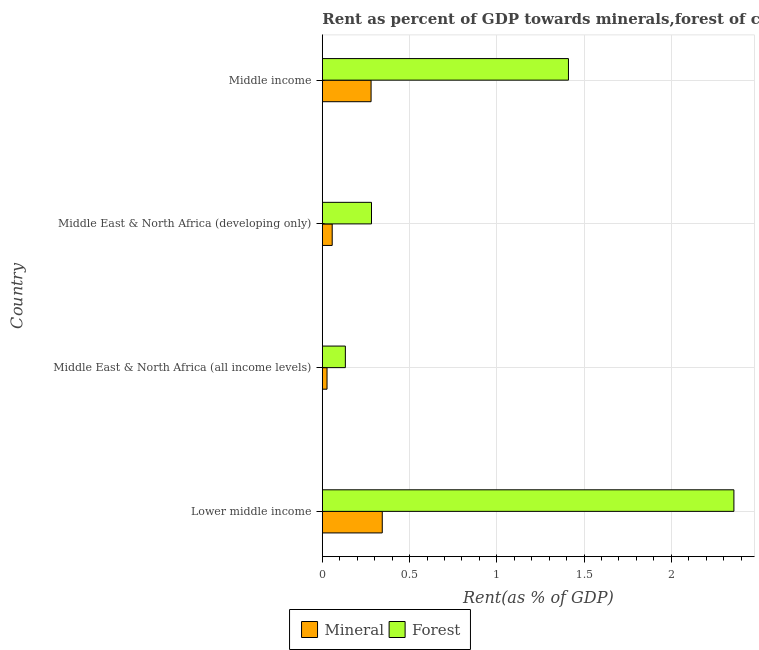How many bars are there on the 1st tick from the bottom?
Provide a succinct answer. 2. What is the label of the 4th group of bars from the top?
Keep it short and to the point. Lower middle income. In how many cases, is the number of bars for a given country not equal to the number of legend labels?
Make the answer very short. 0. What is the mineral rent in Middle income?
Your answer should be very brief. 0.28. Across all countries, what is the maximum mineral rent?
Make the answer very short. 0.34. Across all countries, what is the minimum forest rent?
Offer a terse response. 0.13. In which country was the forest rent maximum?
Ensure brevity in your answer.  Lower middle income. In which country was the mineral rent minimum?
Offer a terse response. Middle East & North Africa (all income levels). What is the total mineral rent in the graph?
Offer a terse response. 0.71. What is the difference between the forest rent in Middle East & North Africa (developing only) and that in Middle income?
Your answer should be very brief. -1.13. What is the difference between the mineral rent in Middle income and the forest rent in Middle East & North Africa (all income levels)?
Your answer should be compact. 0.15. What is the average forest rent per country?
Ensure brevity in your answer.  1.05. What is the difference between the mineral rent and forest rent in Lower middle income?
Offer a very short reply. -2.02. In how many countries, is the forest rent greater than 0.8 %?
Keep it short and to the point. 2. What is the ratio of the mineral rent in Middle East & North Africa (all income levels) to that in Middle East & North Africa (developing only)?
Offer a terse response. 0.47. What is the difference between the highest and the second highest forest rent?
Your response must be concise. 0.95. What is the difference between the highest and the lowest mineral rent?
Your answer should be compact. 0.32. Is the sum of the mineral rent in Lower middle income and Middle East & North Africa (developing only) greater than the maximum forest rent across all countries?
Provide a succinct answer. No. What does the 1st bar from the top in Middle East & North Africa (all income levels) represents?
Give a very brief answer. Forest. What does the 1st bar from the bottom in Lower middle income represents?
Keep it short and to the point. Mineral. Are all the bars in the graph horizontal?
Make the answer very short. Yes. How many countries are there in the graph?
Keep it short and to the point. 4. What is the difference between two consecutive major ticks on the X-axis?
Provide a short and direct response. 0.5. Are the values on the major ticks of X-axis written in scientific E-notation?
Your answer should be compact. No. Where does the legend appear in the graph?
Your answer should be compact. Bottom center. What is the title of the graph?
Your answer should be compact. Rent as percent of GDP towards minerals,forest of countries in 1994. What is the label or title of the X-axis?
Keep it short and to the point. Rent(as % of GDP). What is the label or title of the Y-axis?
Give a very brief answer. Country. What is the Rent(as % of GDP) in Mineral in Lower middle income?
Provide a succinct answer. 0.34. What is the Rent(as % of GDP) of Forest in Lower middle income?
Your answer should be very brief. 2.36. What is the Rent(as % of GDP) of Mineral in Middle East & North Africa (all income levels)?
Your response must be concise. 0.03. What is the Rent(as % of GDP) of Forest in Middle East & North Africa (all income levels)?
Offer a terse response. 0.13. What is the Rent(as % of GDP) in Mineral in Middle East & North Africa (developing only)?
Ensure brevity in your answer.  0.06. What is the Rent(as % of GDP) in Forest in Middle East & North Africa (developing only)?
Offer a very short reply. 0.28. What is the Rent(as % of GDP) in Mineral in Middle income?
Provide a succinct answer. 0.28. What is the Rent(as % of GDP) of Forest in Middle income?
Your response must be concise. 1.41. Across all countries, what is the maximum Rent(as % of GDP) of Mineral?
Provide a short and direct response. 0.34. Across all countries, what is the maximum Rent(as % of GDP) in Forest?
Make the answer very short. 2.36. Across all countries, what is the minimum Rent(as % of GDP) in Mineral?
Keep it short and to the point. 0.03. Across all countries, what is the minimum Rent(as % of GDP) in Forest?
Give a very brief answer. 0.13. What is the total Rent(as % of GDP) of Mineral in the graph?
Provide a succinct answer. 0.71. What is the total Rent(as % of GDP) of Forest in the graph?
Provide a short and direct response. 4.18. What is the difference between the Rent(as % of GDP) in Mineral in Lower middle income and that in Middle East & North Africa (all income levels)?
Keep it short and to the point. 0.32. What is the difference between the Rent(as % of GDP) of Forest in Lower middle income and that in Middle East & North Africa (all income levels)?
Ensure brevity in your answer.  2.23. What is the difference between the Rent(as % of GDP) in Mineral in Lower middle income and that in Middle East & North Africa (developing only)?
Your answer should be very brief. 0.29. What is the difference between the Rent(as % of GDP) in Forest in Lower middle income and that in Middle East & North Africa (developing only)?
Provide a short and direct response. 2.08. What is the difference between the Rent(as % of GDP) of Mineral in Lower middle income and that in Middle income?
Your answer should be compact. 0.06. What is the difference between the Rent(as % of GDP) of Forest in Lower middle income and that in Middle income?
Your answer should be very brief. 0.95. What is the difference between the Rent(as % of GDP) in Mineral in Middle East & North Africa (all income levels) and that in Middle East & North Africa (developing only)?
Provide a succinct answer. -0.03. What is the difference between the Rent(as % of GDP) in Forest in Middle East & North Africa (all income levels) and that in Middle East & North Africa (developing only)?
Give a very brief answer. -0.15. What is the difference between the Rent(as % of GDP) in Mineral in Middle East & North Africa (all income levels) and that in Middle income?
Make the answer very short. -0.25. What is the difference between the Rent(as % of GDP) in Forest in Middle East & North Africa (all income levels) and that in Middle income?
Your answer should be compact. -1.28. What is the difference between the Rent(as % of GDP) in Mineral in Middle East & North Africa (developing only) and that in Middle income?
Your answer should be very brief. -0.22. What is the difference between the Rent(as % of GDP) in Forest in Middle East & North Africa (developing only) and that in Middle income?
Make the answer very short. -1.13. What is the difference between the Rent(as % of GDP) of Mineral in Lower middle income and the Rent(as % of GDP) of Forest in Middle East & North Africa (all income levels)?
Make the answer very short. 0.21. What is the difference between the Rent(as % of GDP) of Mineral in Lower middle income and the Rent(as % of GDP) of Forest in Middle East & North Africa (developing only)?
Provide a succinct answer. 0.06. What is the difference between the Rent(as % of GDP) in Mineral in Lower middle income and the Rent(as % of GDP) in Forest in Middle income?
Your response must be concise. -1.07. What is the difference between the Rent(as % of GDP) of Mineral in Middle East & North Africa (all income levels) and the Rent(as % of GDP) of Forest in Middle East & North Africa (developing only)?
Your answer should be compact. -0.25. What is the difference between the Rent(as % of GDP) in Mineral in Middle East & North Africa (all income levels) and the Rent(as % of GDP) in Forest in Middle income?
Keep it short and to the point. -1.38. What is the difference between the Rent(as % of GDP) of Mineral in Middle East & North Africa (developing only) and the Rent(as % of GDP) of Forest in Middle income?
Give a very brief answer. -1.35. What is the average Rent(as % of GDP) in Mineral per country?
Give a very brief answer. 0.18. What is the average Rent(as % of GDP) of Forest per country?
Offer a terse response. 1.05. What is the difference between the Rent(as % of GDP) in Mineral and Rent(as % of GDP) in Forest in Lower middle income?
Make the answer very short. -2.02. What is the difference between the Rent(as % of GDP) in Mineral and Rent(as % of GDP) in Forest in Middle East & North Africa (all income levels)?
Make the answer very short. -0.11. What is the difference between the Rent(as % of GDP) in Mineral and Rent(as % of GDP) in Forest in Middle East & North Africa (developing only)?
Your response must be concise. -0.23. What is the difference between the Rent(as % of GDP) in Mineral and Rent(as % of GDP) in Forest in Middle income?
Offer a terse response. -1.13. What is the ratio of the Rent(as % of GDP) in Mineral in Lower middle income to that in Middle East & North Africa (all income levels)?
Your response must be concise. 12.76. What is the ratio of the Rent(as % of GDP) in Forest in Lower middle income to that in Middle East & North Africa (all income levels)?
Ensure brevity in your answer.  17.87. What is the ratio of the Rent(as % of GDP) in Mineral in Lower middle income to that in Middle East & North Africa (developing only)?
Offer a terse response. 6.07. What is the ratio of the Rent(as % of GDP) in Forest in Lower middle income to that in Middle East & North Africa (developing only)?
Offer a terse response. 8.37. What is the ratio of the Rent(as % of GDP) in Mineral in Lower middle income to that in Middle income?
Offer a terse response. 1.23. What is the ratio of the Rent(as % of GDP) of Forest in Lower middle income to that in Middle income?
Provide a short and direct response. 1.67. What is the ratio of the Rent(as % of GDP) in Mineral in Middle East & North Africa (all income levels) to that in Middle East & North Africa (developing only)?
Make the answer very short. 0.48. What is the ratio of the Rent(as % of GDP) of Forest in Middle East & North Africa (all income levels) to that in Middle East & North Africa (developing only)?
Give a very brief answer. 0.47. What is the ratio of the Rent(as % of GDP) of Mineral in Middle East & North Africa (all income levels) to that in Middle income?
Offer a terse response. 0.1. What is the ratio of the Rent(as % of GDP) in Forest in Middle East & North Africa (all income levels) to that in Middle income?
Keep it short and to the point. 0.09. What is the ratio of the Rent(as % of GDP) in Mineral in Middle East & North Africa (developing only) to that in Middle income?
Make the answer very short. 0.2. What is the ratio of the Rent(as % of GDP) in Forest in Middle East & North Africa (developing only) to that in Middle income?
Your answer should be very brief. 0.2. What is the difference between the highest and the second highest Rent(as % of GDP) in Mineral?
Offer a very short reply. 0.06. What is the difference between the highest and the second highest Rent(as % of GDP) of Forest?
Ensure brevity in your answer.  0.95. What is the difference between the highest and the lowest Rent(as % of GDP) in Mineral?
Your answer should be very brief. 0.32. What is the difference between the highest and the lowest Rent(as % of GDP) of Forest?
Offer a very short reply. 2.23. 